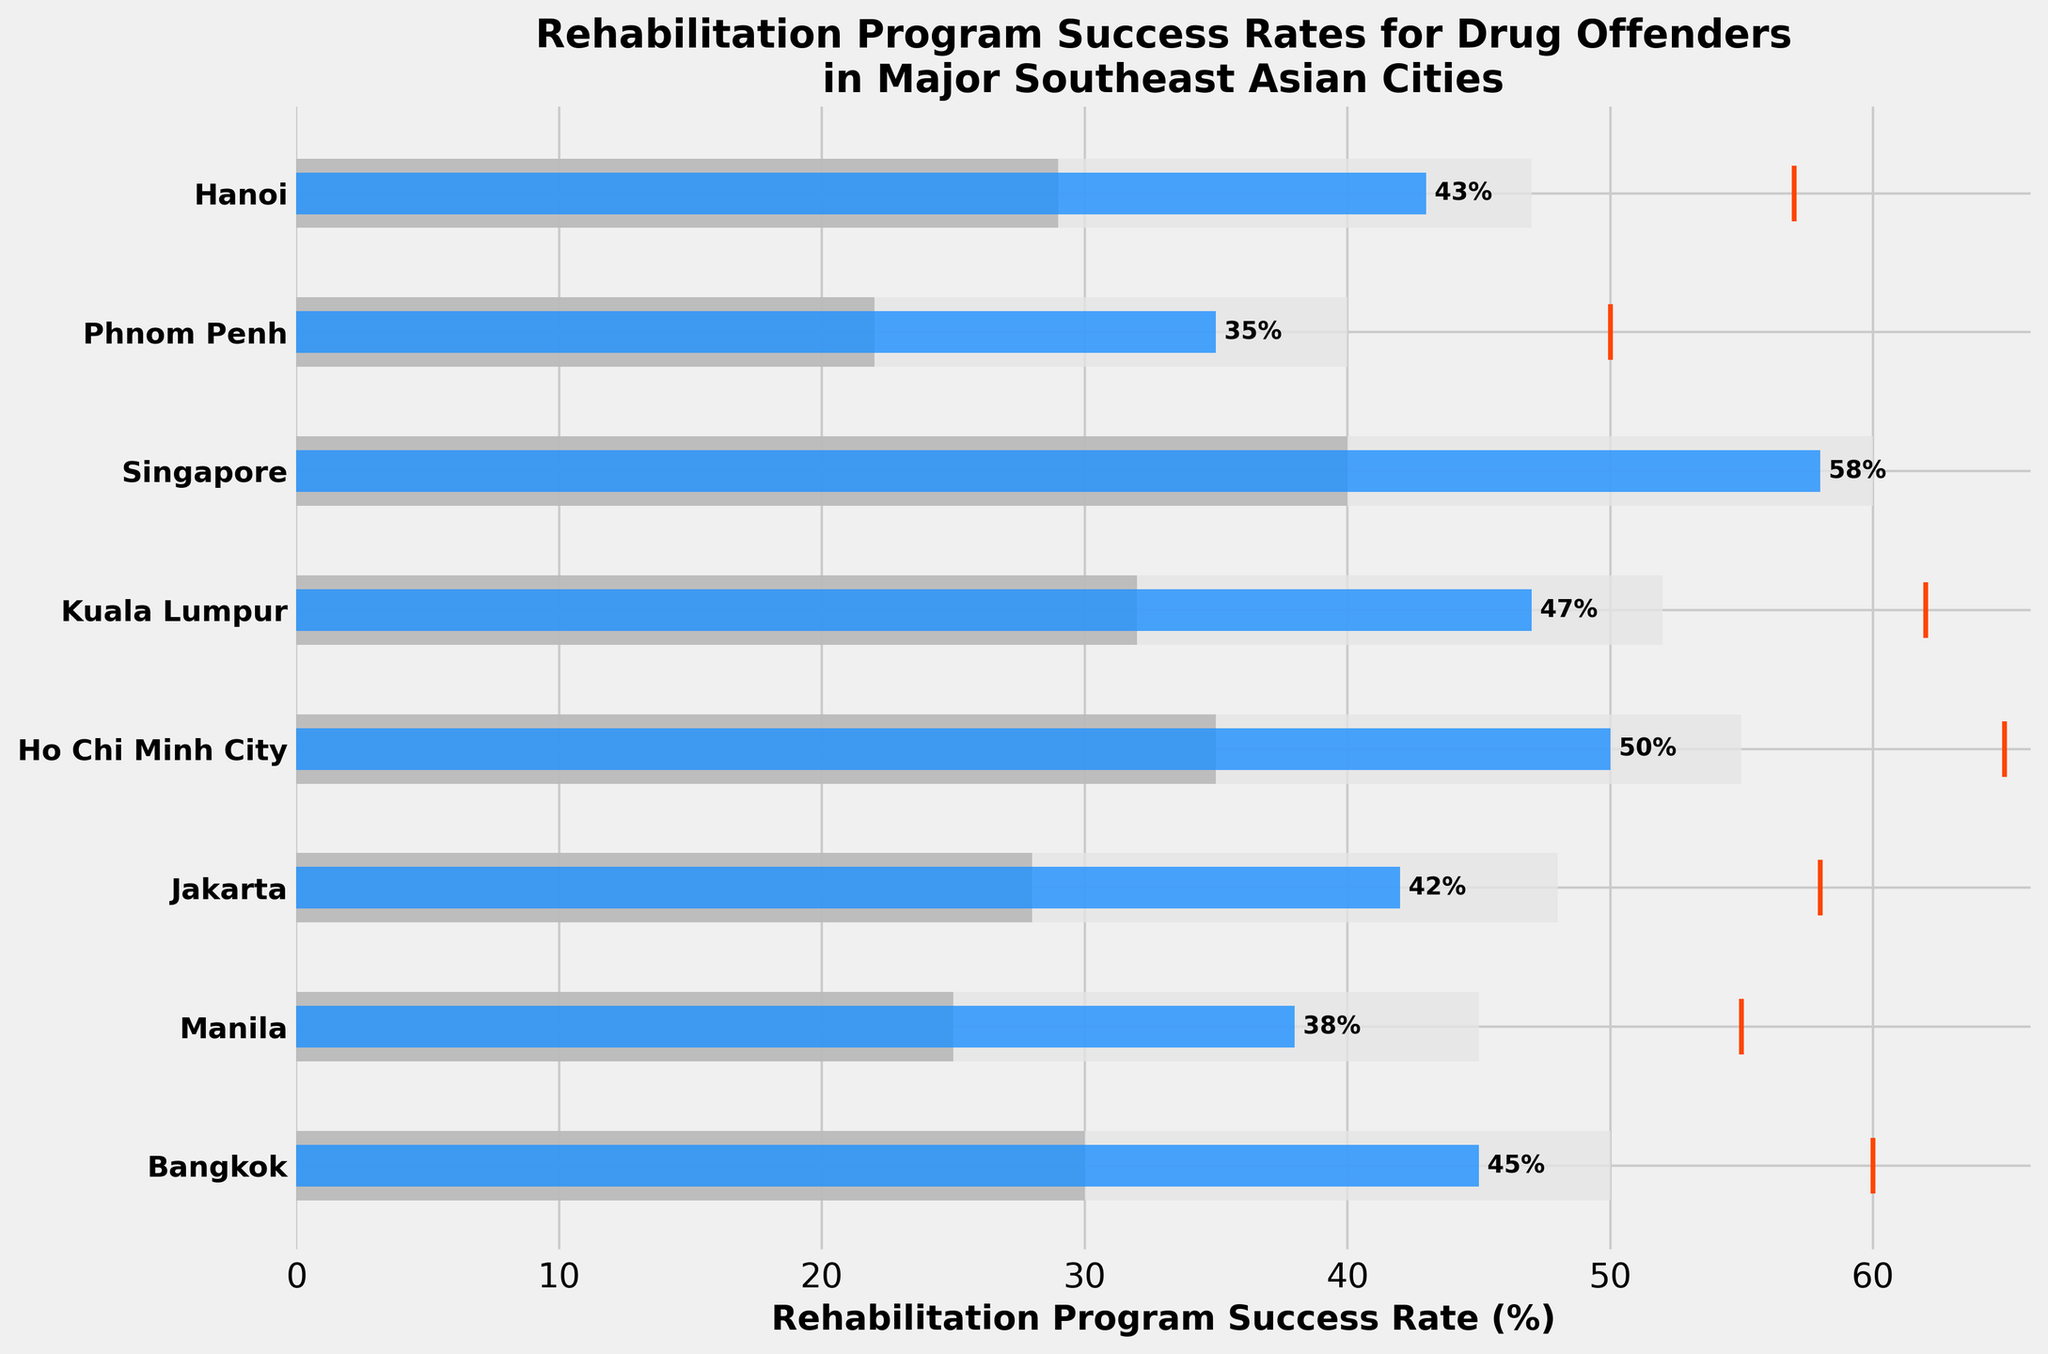What is the title of the figure? The title is usually displayed at the top of the figure. In this case, it states the main subject of the visualization.
Answer: 'Rehabilitation Program Success Rates for Drug Offenders in Major Southeast Asian Cities' Which city has the highest actual rehabilitation program success rate? You need to identify the city with the longest blue bar, which represents the actual success rate.
Answer: Singapore How does the actual success rate in Jakarta compare to its target? Compare the length of the blue bar to the position of the red line for Jakarta. The blue bar is shorter, meaning the actual success rate is below the target.
Answer: Below target Which city has the smallest gap between actual and target success rates? Calculate the difference between the actual and target success rates for each city by comparing the blue bar length and red line position. The smaller the gap, the closer the blue bar is to the red line.
Answer: Ho Chi Minh City Among all cities, which one has the actual success rate closest to its second range threshold? Identify the city where the actual rate (blue bar) is close to the second range (color #b3b3b3) boundary while being still within or nearly touching that range.
Answer: Hanoi Sum up the actual success rates of Manila and Bangkok. Add the values represented by the blue bars for Manila and Bangkok.
Answer: 38 + 45 = 83 What is the average target rehabilitation program success rate across all cities? Sum the target rates for all cities and divide by the number of cities. [(60+55+58+65+62+70+50+57)/8]
Answer: 59.625 What are the color bands representing different range values in the figure? Identify the three gradient colors from light to dark that signify the ranges in the figure.
Answer: Light gray, medium gray, dark gray Which city has the largest gap between its actual success rate and the highest range3 limit? Determine the difference for each city by subtracting the actual success rates from the corresponding highest Range3 value. Identifying the largest difference.
Answer: Phnom Penh (50 - 35 = 15) How do the success rates of Hanoi and Kuala Lumpur compare against each city's target? Check the actual and target success rates of Hanoi and Kuala Lumpur by observing the distance between the blue bars and the red lines. Both Hanoi and Kuala Lumpur actual rates are below their targets, with a similar gap size.
Answer: Both below target but Kuala Lumpur is closer How many cities have an actual success rate higher than 45%? Count the number of blue bars representing actual success rates that extend beyond the 45% value.
Answer: 4 